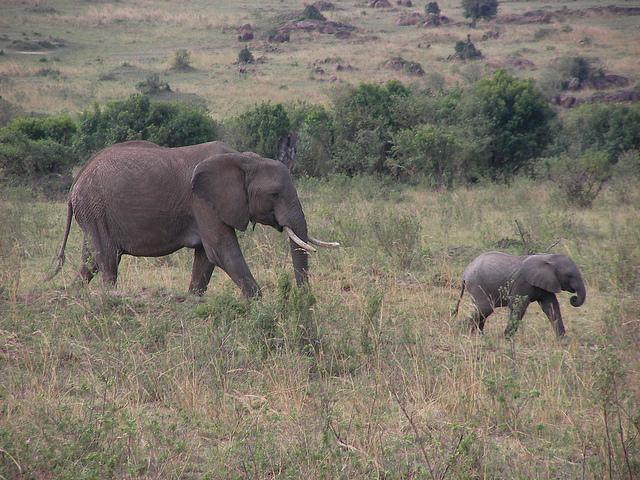How many baby elephants are in the photo?
Give a very brief answer. 1. How many elephants are there?
Give a very brief answer. 2. 